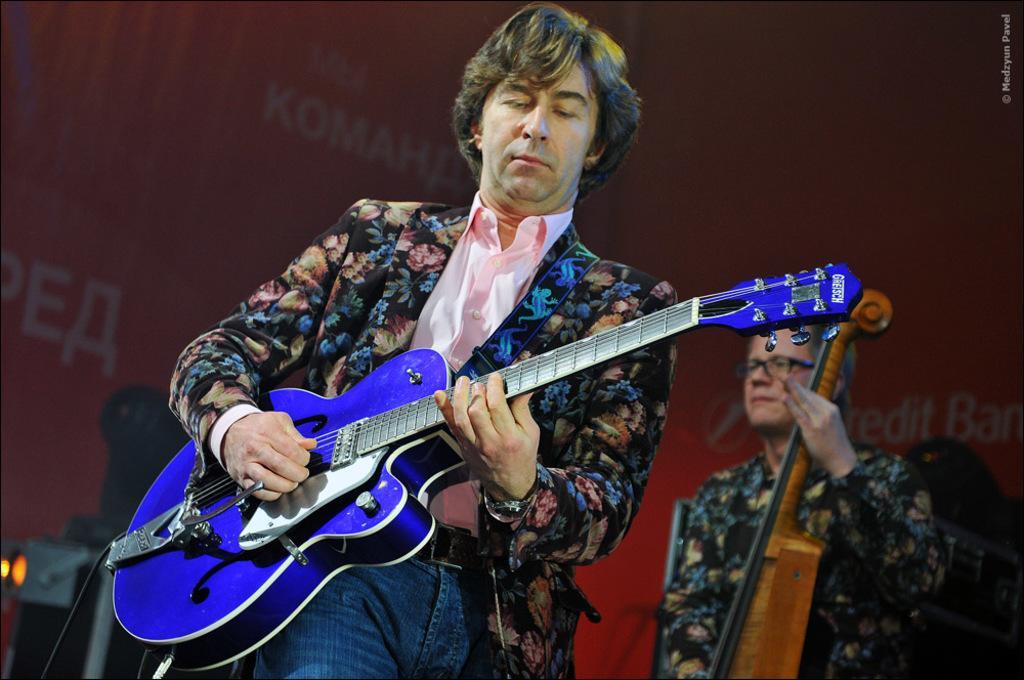Please provide a concise description of this image. In this image there are two musicians performing at the stage. The person standing in the center is holding a blue colour guitar in his hand. The person at the right side is holding a musical instrument. In the background there is a red colour wall. 